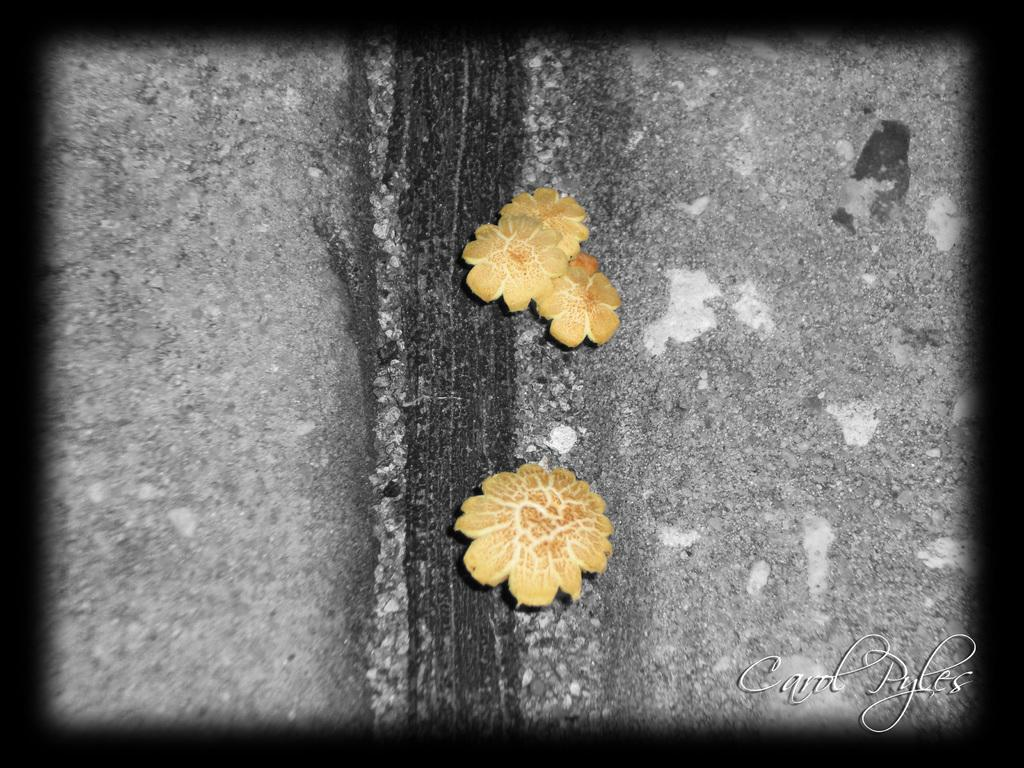What color are the objects in the image? The objects in the image are yellow. What do the objects resemble? The objects resemble flowers. What is the color of the surface on which the objects are placed? The surface is ash, white, and black colored. How many books are stacked on the pan in the image? There are no books or pans present in the image. The objects in the image are yellow and resemble flowers, placed on an ash, white, and black colored surface. 